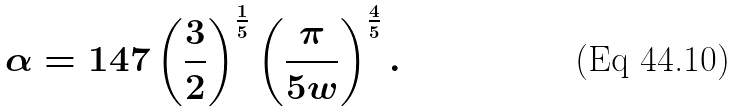<formula> <loc_0><loc_0><loc_500><loc_500>\alpha = 1 4 7 \left ( \frac { 3 } { 2 } \right ) ^ { \frac { 1 } { 5 } } \left ( \frac { \pi } { 5 w } \right ) ^ { \frac { 4 } { 5 } } .</formula> 